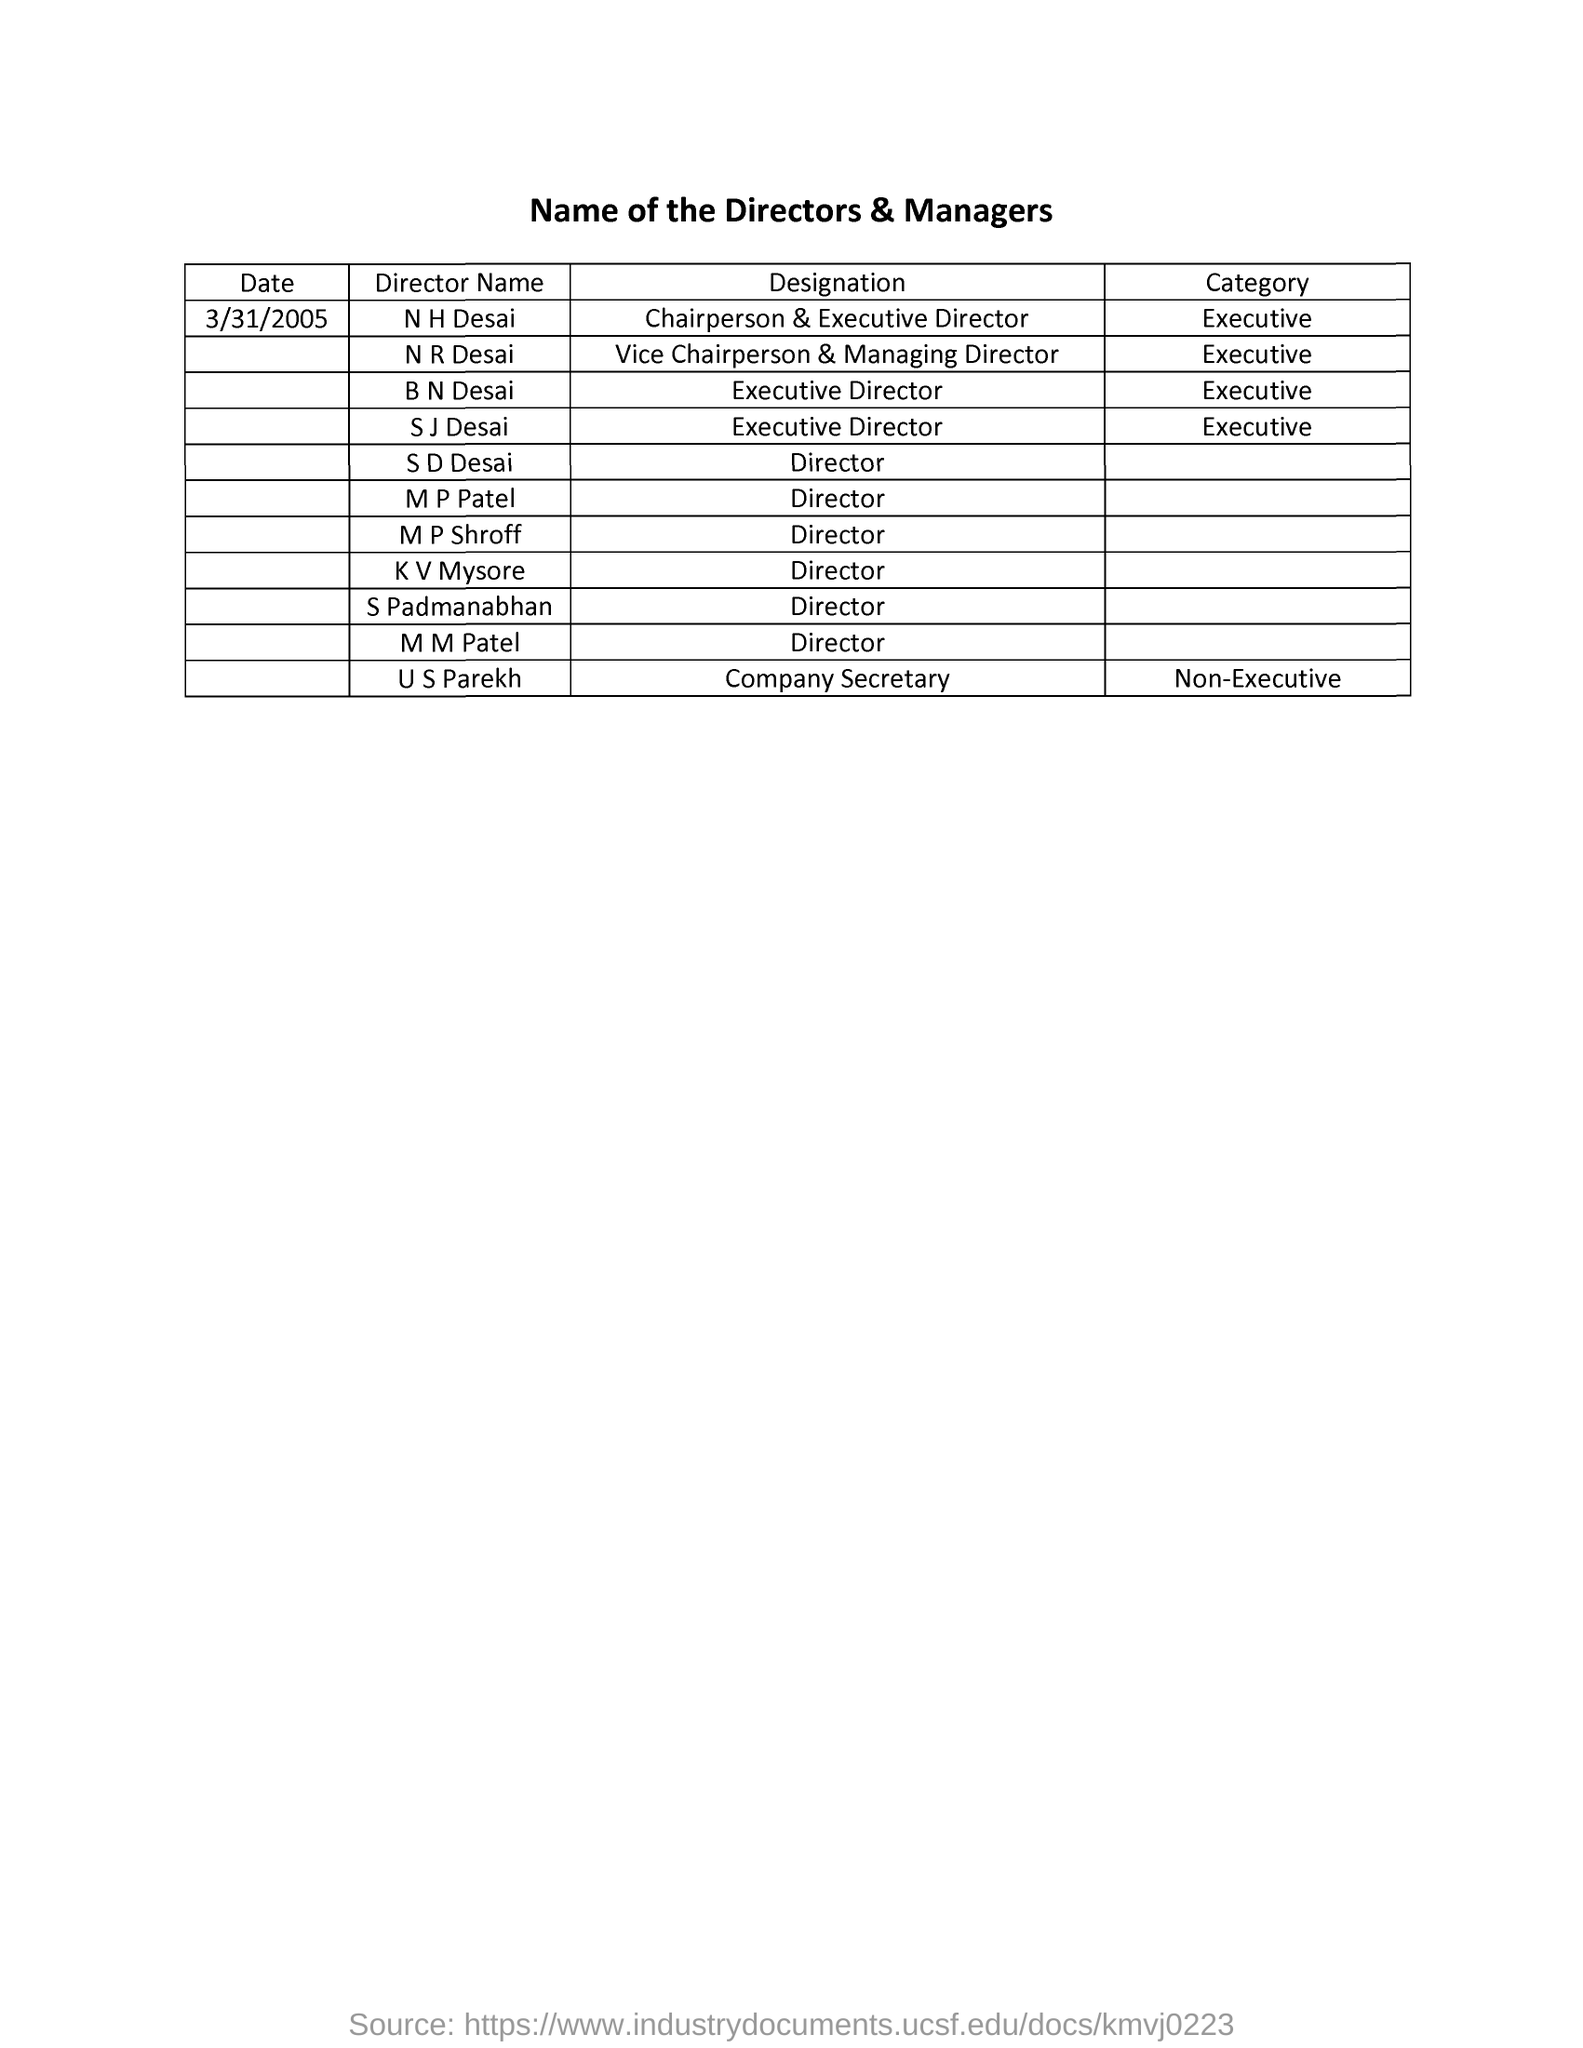Why might a company choose to have both a Chairperson & Executive Director and a Vice Chairperson & Managing Director? A company may opt for this structure to distribute the hefty responsibilities of running a large corporation, ensuring more focused and efficient management. This can prevent decision-making bottlenecks and improve oversight. It can also provide continuity in leadership during absences or transitions among the top executives. 